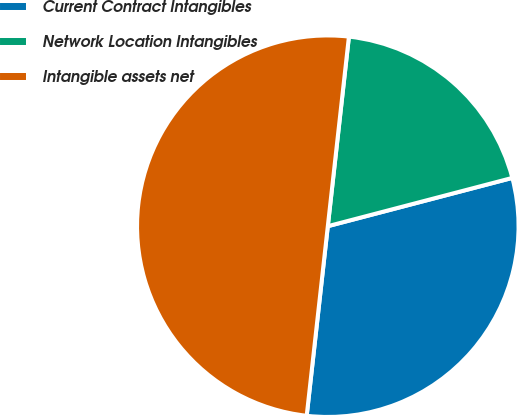Convert chart to OTSL. <chart><loc_0><loc_0><loc_500><loc_500><pie_chart><fcel>Current Contract Intangibles<fcel>Network Location Intangibles<fcel>Intangible assets net<nl><fcel>30.84%<fcel>19.16%<fcel>50.0%<nl></chart> 